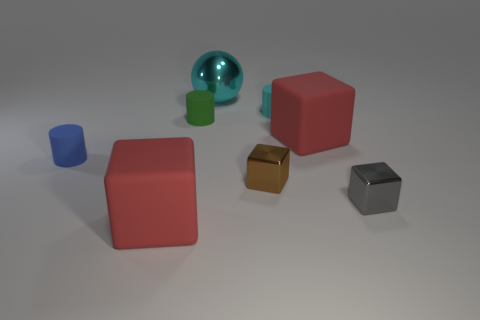Subtract 1 cubes. How many cubes are left? 3 Add 1 cyan metal objects. How many objects exist? 9 Subtract all cylinders. How many objects are left? 5 Subtract all blue cylinders. Subtract all tiny blocks. How many objects are left? 5 Add 8 red rubber things. How many red rubber things are left? 10 Add 1 brown metallic things. How many brown metallic things exist? 2 Subtract 0 brown cylinders. How many objects are left? 8 